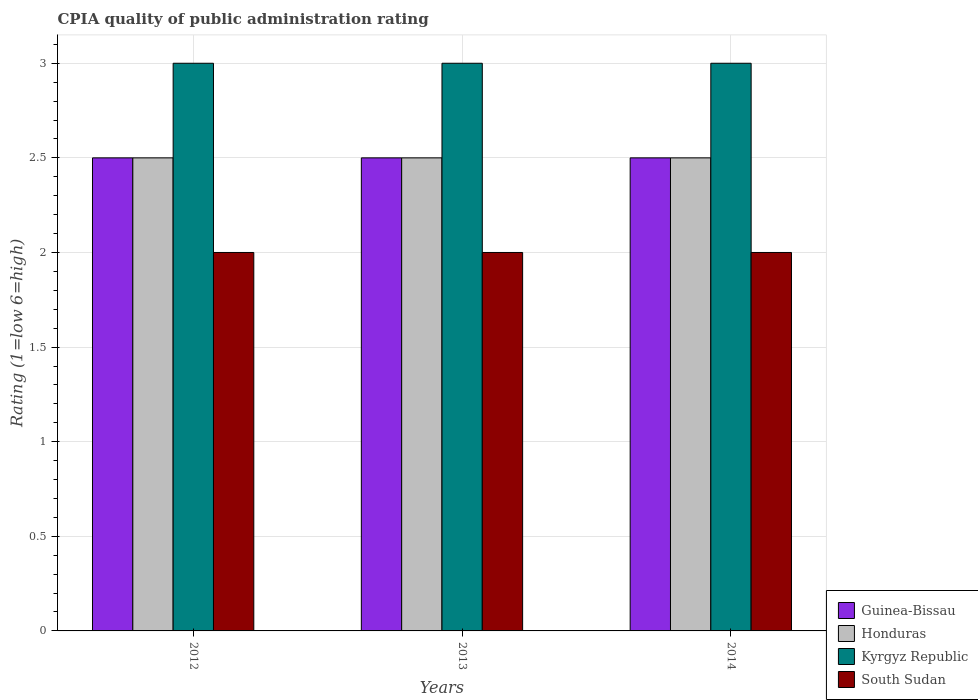How many different coloured bars are there?
Offer a very short reply. 4. Are the number of bars per tick equal to the number of legend labels?
Offer a very short reply. Yes. Are the number of bars on each tick of the X-axis equal?
Make the answer very short. Yes. How many bars are there on the 3rd tick from the left?
Keep it short and to the point. 4. How many bars are there on the 1st tick from the right?
Keep it short and to the point. 4. Across all years, what is the maximum CPIA rating in Honduras?
Ensure brevity in your answer.  2.5. Across all years, what is the minimum CPIA rating in Honduras?
Ensure brevity in your answer.  2.5. In which year was the CPIA rating in South Sudan minimum?
Your answer should be compact. 2012. In how many years, is the CPIA rating in Guinea-Bissau greater than 0.2?
Your response must be concise. 3. Is the sum of the CPIA rating in Guinea-Bissau in 2013 and 2014 greater than the maximum CPIA rating in South Sudan across all years?
Your answer should be compact. Yes. Is it the case that in every year, the sum of the CPIA rating in Honduras and CPIA rating in Kyrgyz Republic is greater than the sum of CPIA rating in South Sudan and CPIA rating in Guinea-Bissau?
Your answer should be very brief. Yes. What does the 2nd bar from the left in 2012 represents?
Provide a succinct answer. Honduras. What does the 2nd bar from the right in 2013 represents?
Provide a succinct answer. Kyrgyz Republic. How many years are there in the graph?
Ensure brevity in your answer.  3. What is the difference between two consecutive major ticks on the Y-axis?
Your answer should be compact. 0.5. Are the values on the major ticks of Y-axis written in scientific E-notation?
Offer a terse response. No. How many legend labels are there?
Offer a terse response. 4. How are the legend labels stacked?
Ensure brevity in your answer.  Vertical. What is the title of the graph?
Make the answer very short. CPIA quality of public administration rating. What is the label or title of the X-axis?
Offer a terse response. Years. What is the label or title of the Y-axis?
Your answer should be compact. Rating (1=low 6=high). What is the Rating (1=low 6=high) in Honduras in 2012?
Ensure brevity in your answer.  2.5. What is the Rating (1=low 6=high) in Kyrgyz Republic in 2012?
Offer a very short reply. 3. What is the Rating (1=low 6=high) of South Sudan in 2012?
Provide a short and direct response. 2. What is the Rating (1=low 6=high) in South Sudan in 2014?
Your response must be concise. 2. Across all years, what is the maximum Rating (1=low 6=high) in Guinea-Bissau?
Give a very brief answer. 2.5. Across all years, what is the maximum Rating (1=low 6=high) in Kyrgyz Republic?
Offer a very short reply. 3. Across all years, what is the minimum Rating (1=low 6=high) in Guinea-Bissau?
Make the answer very short. 2.5. Across all years, what is the minimum Rating (1=low 6=high) of Honduras?
Your answer should be very brief. 2.5. What is the total Rating (1=low 6=high) in Guinea-Bissau in the graph?
Give a very brief answer. 7.5. What is the total Rating (1=low 6=high) of Honduras in the graph?
Make the answer very short. 7.5. What is the difference between the Rating (1=low 6=high) of South Sudan in 2012 and that in 2014?
Ensure brevity in your answer.  0. What is the difference between the Rating (1=low 6=high) of Guinea-Bissau in 2013 and that in 2014?
Offer a terse response. 0. What is the difference between the Rating (1=low 6=high) in Kyrgyz Republic in 2013 and that in 2014?
Your response must be concise. 0. What is the difference between the Rating (1=low 6=high) in Guinea-Bissau in 2012 and the Rating (1=low 6=high) in Kyrgyz Republic in 2013?
Offer a very short reply. -0.5. What is the difference between the Rating (1=low 6=high) in Honduras in 2012 and the Rating (1=low 6=high) in South Sudan in 2013?
Your response must be concise. 0.5. What is the difference between the Rating (1=low 6=high) of Kyrgyz Republic in 2012 and the Rating (1=low 6=high) of South Sudan in 2013?
Offer a terse response. 1. What is the difference between the Rating (1=low 6=high) of Guinea-Bissau in 2012 and the Rating (1=low 6=high) of Honduras in 2014?
Your response must be concise. 0. What is the difference between the Rating (1=low 6=high) of Guinea-Bissau in 2012 and the Rating (1=low 6=high) of South Sudan in 2014?
Offer a terse response. 0.5. What is the difference between the Rating (1=low 6=high) of Honduras in 2012 and the Rating (1=low 6=high) of Kyrgyz Republic in 2014?
Offer a very short reply. -0.5. What is the difference between the Rating (1=low 6=high) in Honduras in 2012 and the Rating (1=low 6=high) in South Sudan in 2014?
Ensure brevity in your answer.  0.5. What is the difference between the Rating (1=low 6=high) of Kyrgyz Republic in 2012 and the Rating (1=low 6=high) of South Sudan in 2014?
Your answer should be compact. 1. What is the difference between the Rating (1=low 6=high) of Honduras in 2013 and the Rating (1=low 6=high) of South Sudan in 2014?
Ensure brevity in your answer.  0.5. What is the difference between the Rating (1=low 6=high) in Kyrgyz Republic in 2013 and the Rating (1=low 6=high) in South Sudan in 2014?
Give a very brief answer. 1. What is the average Rating (1=low 6=high) of Honduras per year?
Offer a very short reply. 2.5. What is the average Rating (1=low 6=high) of Kyrgyz Republic per year?
Offer a terse response. 3. In the year 2012, what is the difference between the Rating (1=low 6=high) of Guinea-Bissau and Rating (1=low 6=high) of Honduras?
Your response must be concise. 0. In the year 2012, what is the difference between the Rating (1=low 6=high) of Guinea-Bissau and Rating (1=low 6=high) of Kyrgyz Republic?
Keep it short and to the point. -0.5. In the year 2012, what is the difference between the Rating (1=low 6=high) of Guinea-Bissau and Rating (1=low 6=high) of South Sudan?
Your response must be concise. 0.5. In the year 2013, what is the difference between the Rating (1=low 6=high) in Guinea-Bissau and Rating (1=low 6=high) in Honduras?
Ensure brevity in your answer.  0. In the year 2013, what is the difference between the Rating (1=low 6=high) in Kyrgyz Republic and Rating (1=low 6=high) in South Sudan?
Offer a very short reply. 1. In the year 2014, what is the difference between the Rating (1=low 6=high) in Guinea-Bissau and Rating (1=low 6=high) in Honduras?
Keep it short and to the point. 0. In the year 2014, what is the difference between the Rating (1=low 6=high) in Guinea-Bissau and Rating (1=low 6=high) in South Sudan?
Your response must be concise. 0.5. In the year 2014, what is the difference between the Rating (1=low 6=high) of Honduras and Rating (1=low 6=high) of Kyrgyz Republic?
Give a very brief answer. -0.5. In the year 2014, what is the difference between the Rating (1=low 6=high) of Kyrgyz Republic and Rating (1=low 6=high) of South Sudan?
Your answer should be very brief. 1. What is the ratio of the Rating (1=low 6=high) of Honduras in 2012 to that in 2013?
Your answer should be very brief. 1. What is the ratio of the Rating (1=low 6=high) in South Sudan in 2012 to that in 2013?
Provide a succinct answer. 1. What is the ratio of the Rating (1=low 6=high) of Guinea-Bissau in 2012 to that in 2014?
Provide a succinct answer. 1. What is the ratio of the Rating (1=low 6=high) in Honduras in 2012 to that in 2014?
Your answer should be compact. 1. What is the ratio of the Rating (1=low 6=high) in Kyrgyz Republic in 2012 to that in 2014?
Make the answer very short. 1. What is the ratio of the Rating (1=low 6=high) in South Sudan in 2012 to that in 2014?
Your response must be concise. 1. What is the ratio of the Rating (1=low 6=high) of Guinea-Bissau in 2013 to that in 2014?
Your answer should be compact. 1. What is the ratio of the Rating (1=low 6=high) of Kyrgyz Republic in 2013 to that in 2014?
Provide a short and direct response. 1. What is the difference between the highest and the second highest Rating (1=low 6=high) in Guinea-Bissau?
Give a very brief answer. 0. What is the difference between the highest and the second highest Rating (1=low 6=high) in Honduras?
Make the answer very short. 0. What is the difference between the highest and the second highest Rating (1=low 6=high) in Kyrgyz Republic?
Offer a terse response. 0. What is the difference between the highest and the lowest Rating (1=low 6=high) of Honduras?
Provide a short and direct response. 0. What is the difference between the highest and the lowest Rating (1=low 6=high) in Kyrgyz Republic?
Your answer should be compact. 0. 